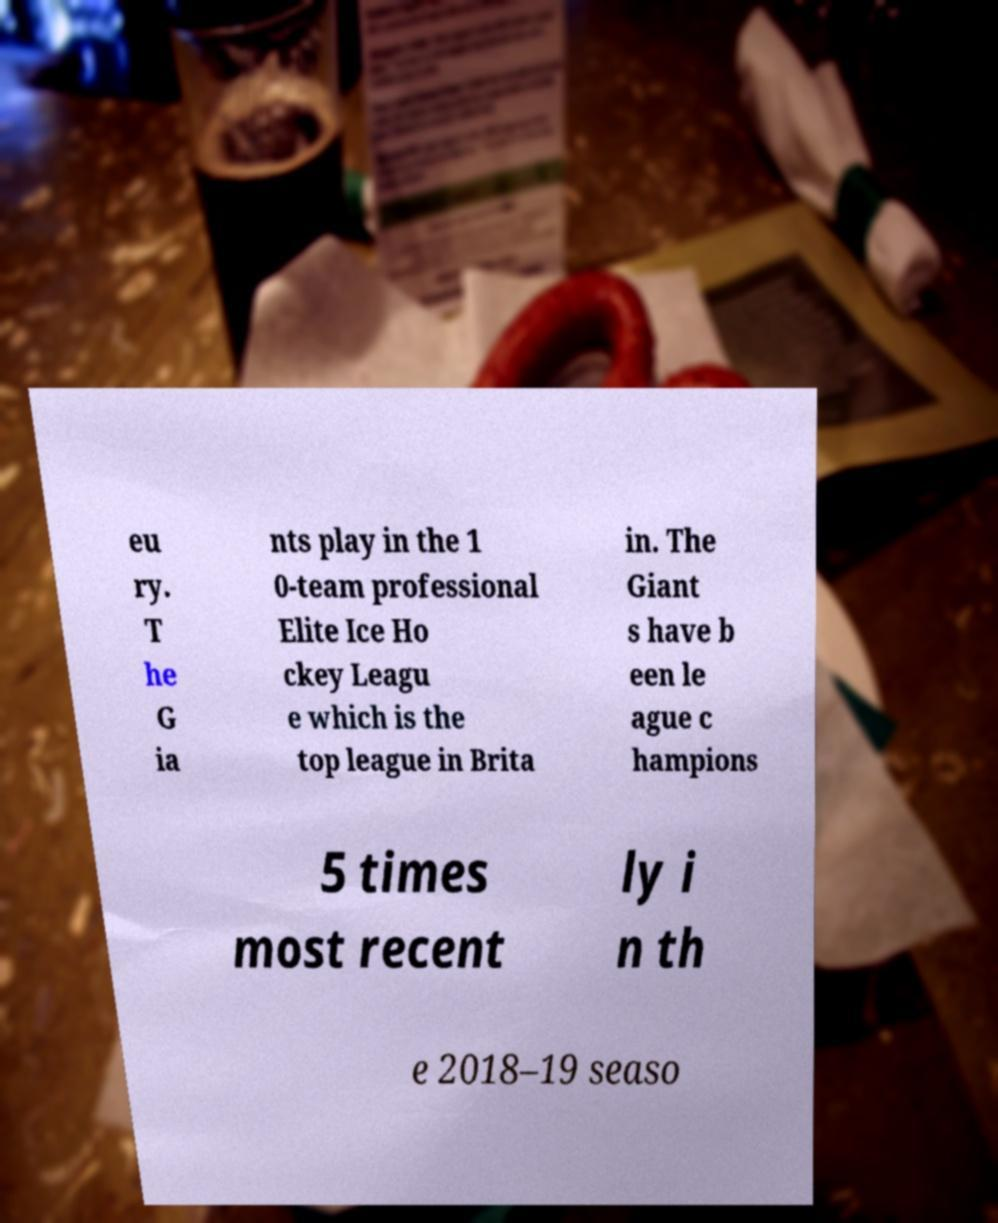I need the written content from this picture converted into text. Can you do that? eu ry. T he G ia nts play in the 1 0-team professional Elite Ice Ho ckey Leagu e which is the top league in Brita in. The Giant s have b een le ague c hampions 5 times most recent ly i n th e 2018–19 seaso 